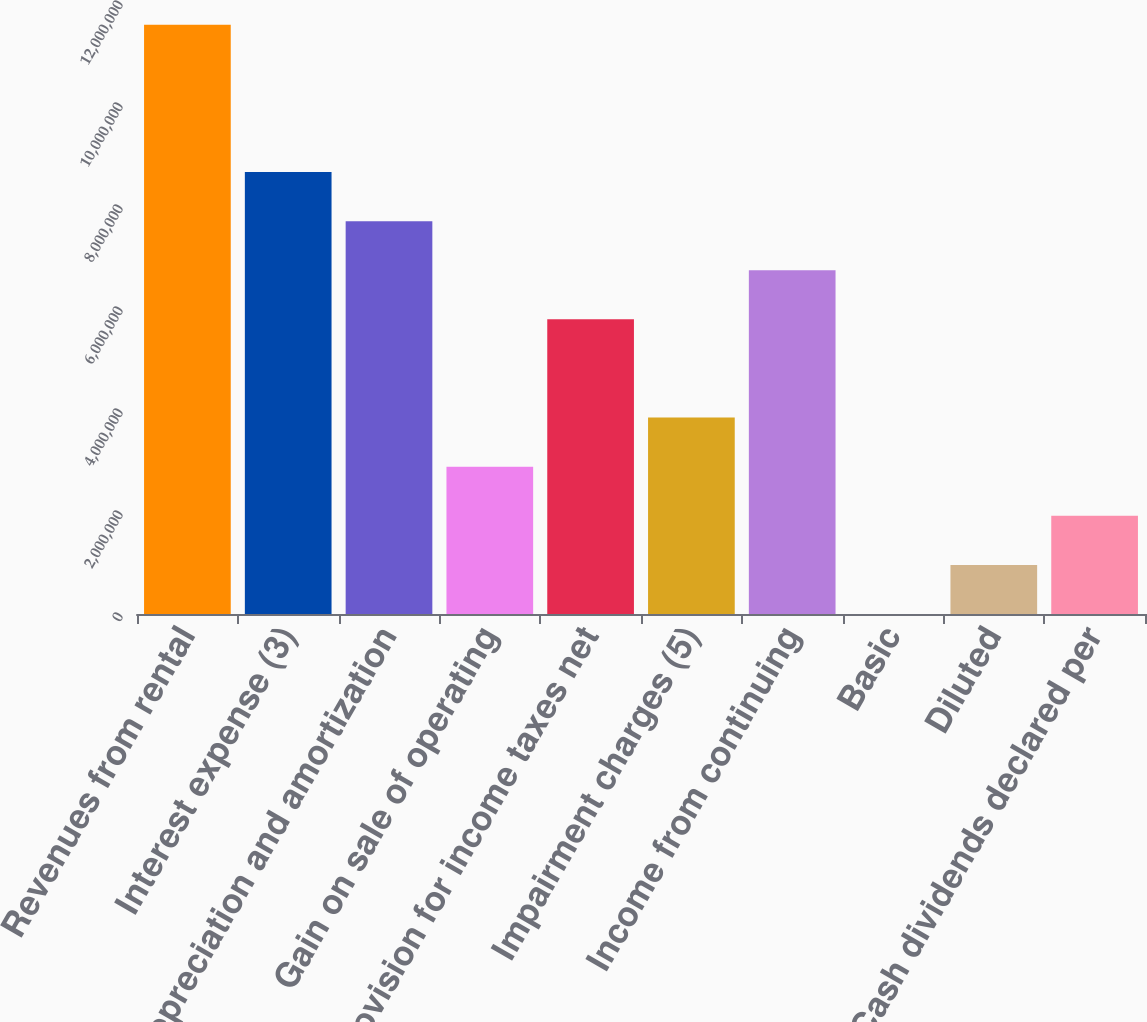Convert chart to OTSL. <chart><loc_0><loc_0><loc_500><loc_500><bar_chart><fcel>Revenues from rental<fcel>Interest expense (3)<fcel>Depreciation and amortization<fcel>Gain on sale of operating<fcel>Provision for income taxes net<fcel>Impairment charges (5)<fcel>Income from continuing<fcel>Basic<fcel>Diluted<fcel>Cash dividends declared per<nl><fcel>1.15545e+07<fcel>8.66589e+06<fcel>7.70301e+06<fcel>2.88863e+06<fcel>5.77726e+06<fcel>3.8515e+06<fcel>6.74013e+06<fcel>0.1<fcel>962876<fcel>1.92575e+06<nl></chart> 